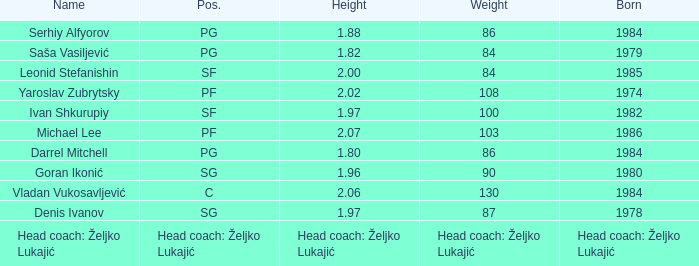What was michael lee's position? PF. 